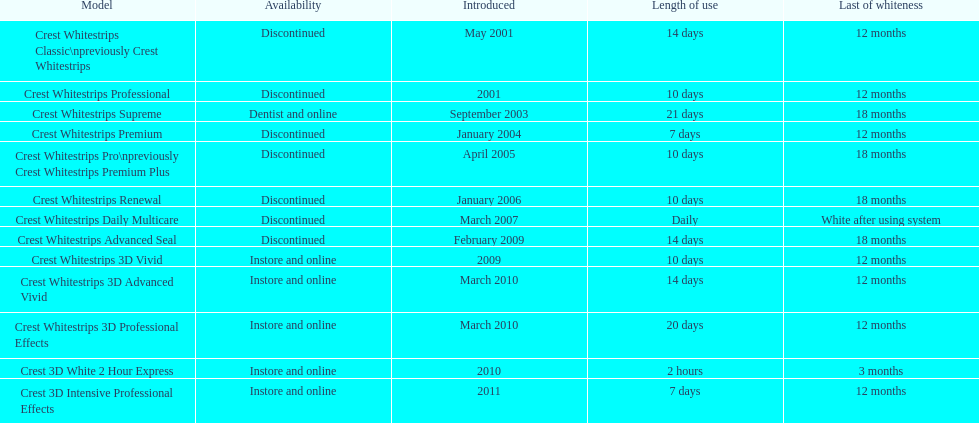Which model features the highest 'time of use' to 'end of whiteness' ratio? Crest Whitestrips Supreme. 